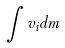<formula> <loc_0><loc_0><loc_500><loc_500>\int v _ { i } d m</formula> 